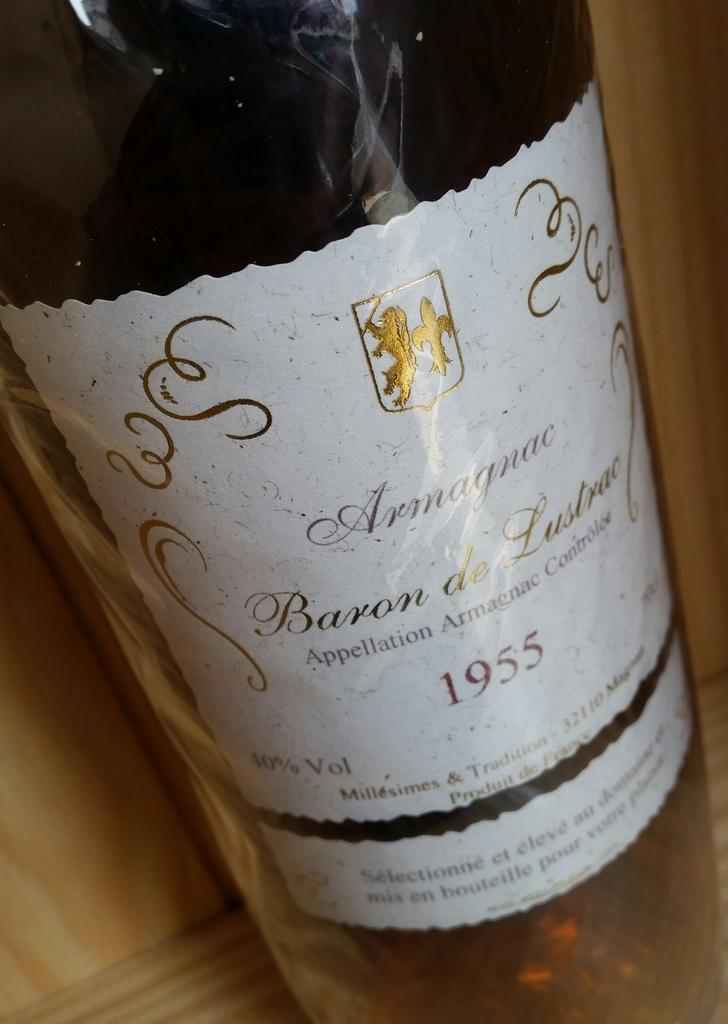What is the main object in the image? There is a wine bottle in the image. What type of match is being used to light the candles during the rainstorm in the image? There is no mention of candles, rainstorm, or matches in the image. The image only contains a wine bottle. 